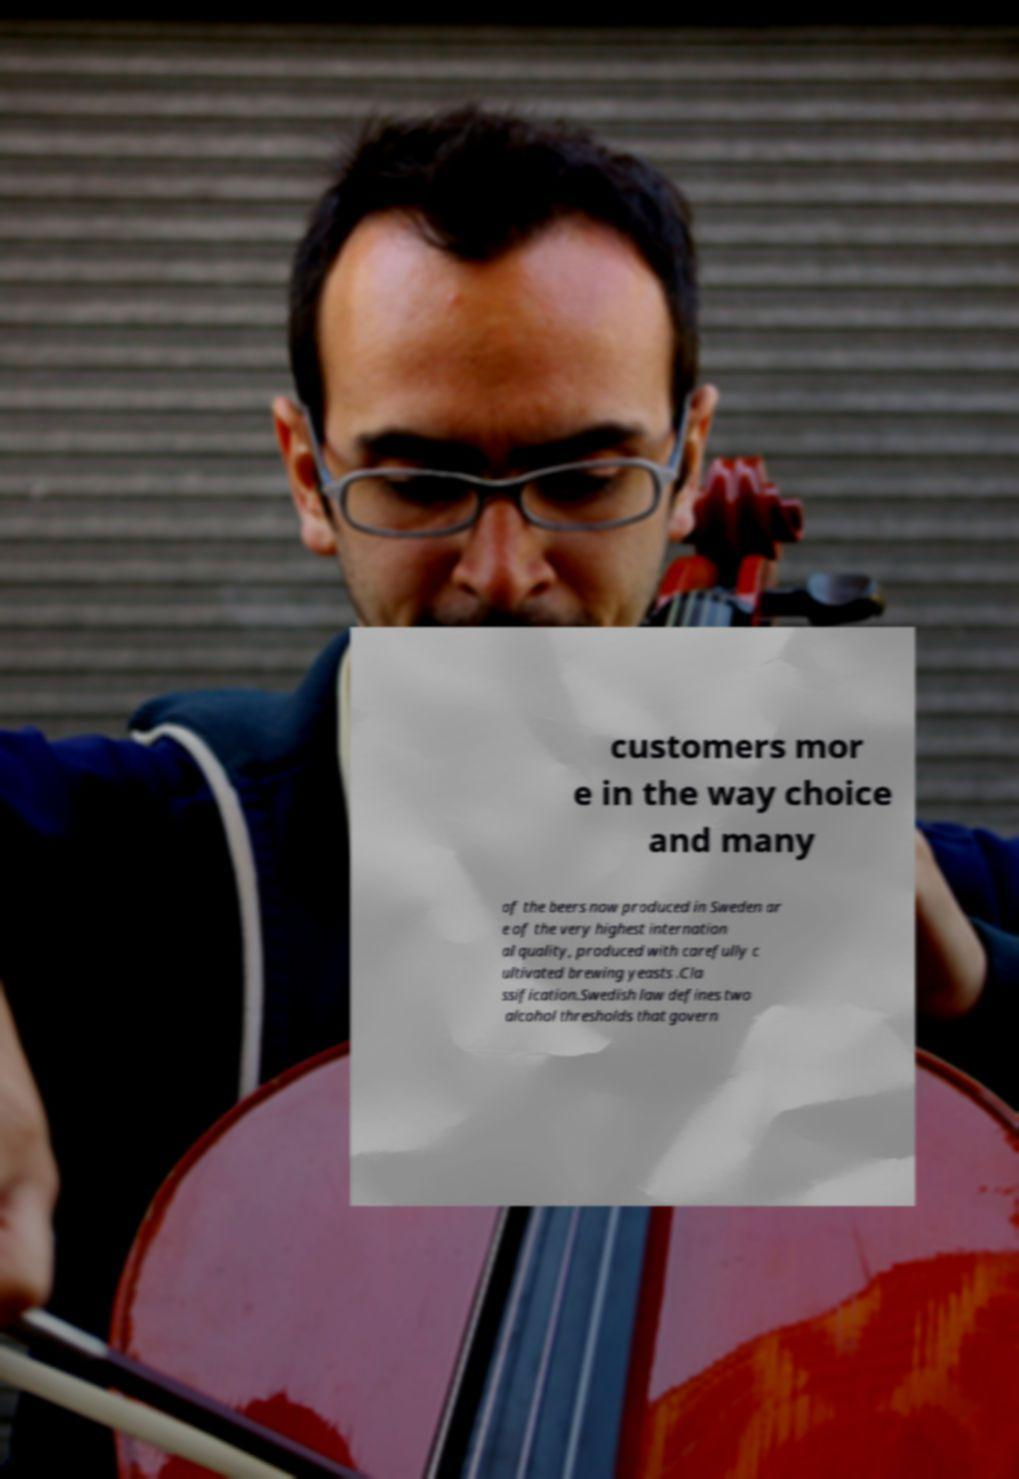Can you read and provide the text displayed in the image?This photo seems to have some interesting text. Can you extract and type it out for me? customers mor e in the way choice and many of the beers now produced in Sweden ar e of the very highest internation al quality, produced with carefully c ultivated brewing yeasts .Cla ssification.Swedish law defines two alcohol thresholds that govern 